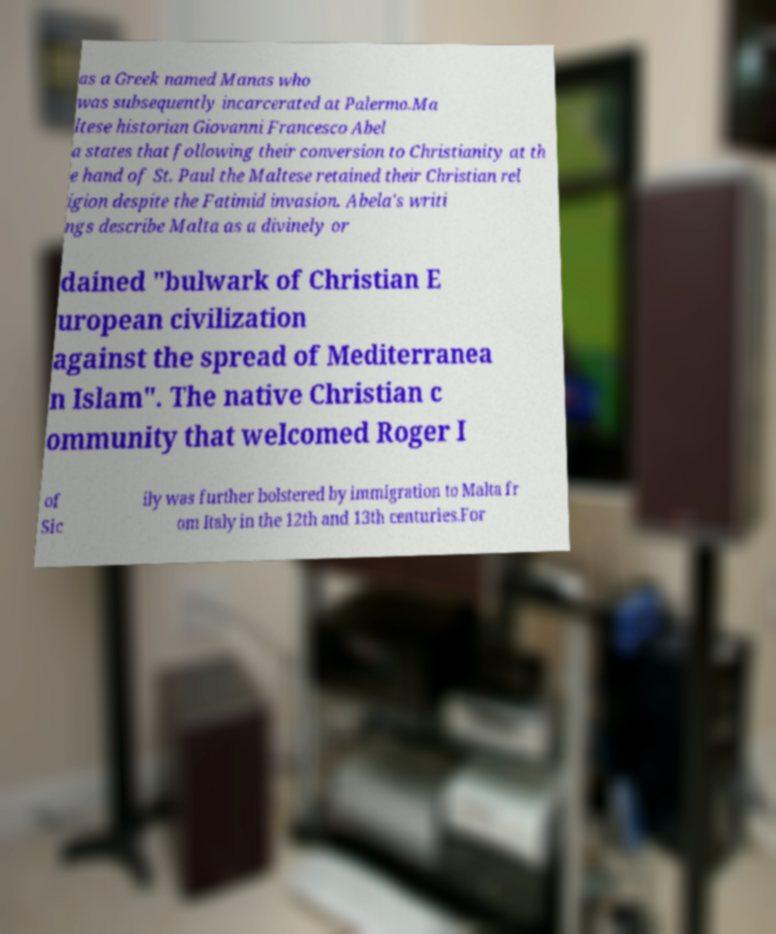Could you assist in decoding the text presented in this image and type it out clearly? as a Greek named Manas who was subsequently incarcerated at Palermo.Ma ltese historian Giovanni Francesco Abel a states that following their conversion to Christianity at th e hand of St. Paul the Maltese retained their Christian rel igion despite the Fatimid invasion. Abela's writi ngs describe Malta as a divinely or dained "bulwark of Christian E uropean civilization against the spread of Mediterranea n Islam". The native Christian c ommunity that welcomed Roger I of Sic ily was further bolstered by immigration to Malta fr om Italy in the 12th and 13th centuries.For 